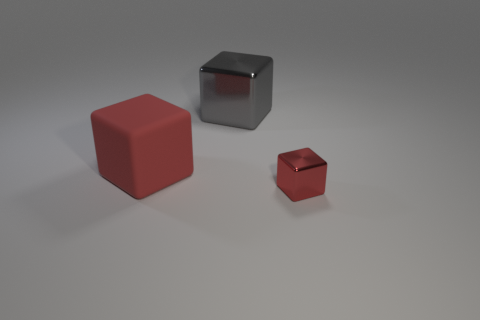Does the arrangement of the cubes suggest any particular pattern or purpose? The varying sizes and orderly spacing between the cubes might indicate a study in perspective or could be an artistic representation of objects in space, emphasizing composition and the play of light and shadows. Could these cubes represent anything beyond their shapes? Certainly, they could symbolize concepts such as progression, differences in scale or importance, or even serve as stand-ins for entities in a simplified model or simulation. 